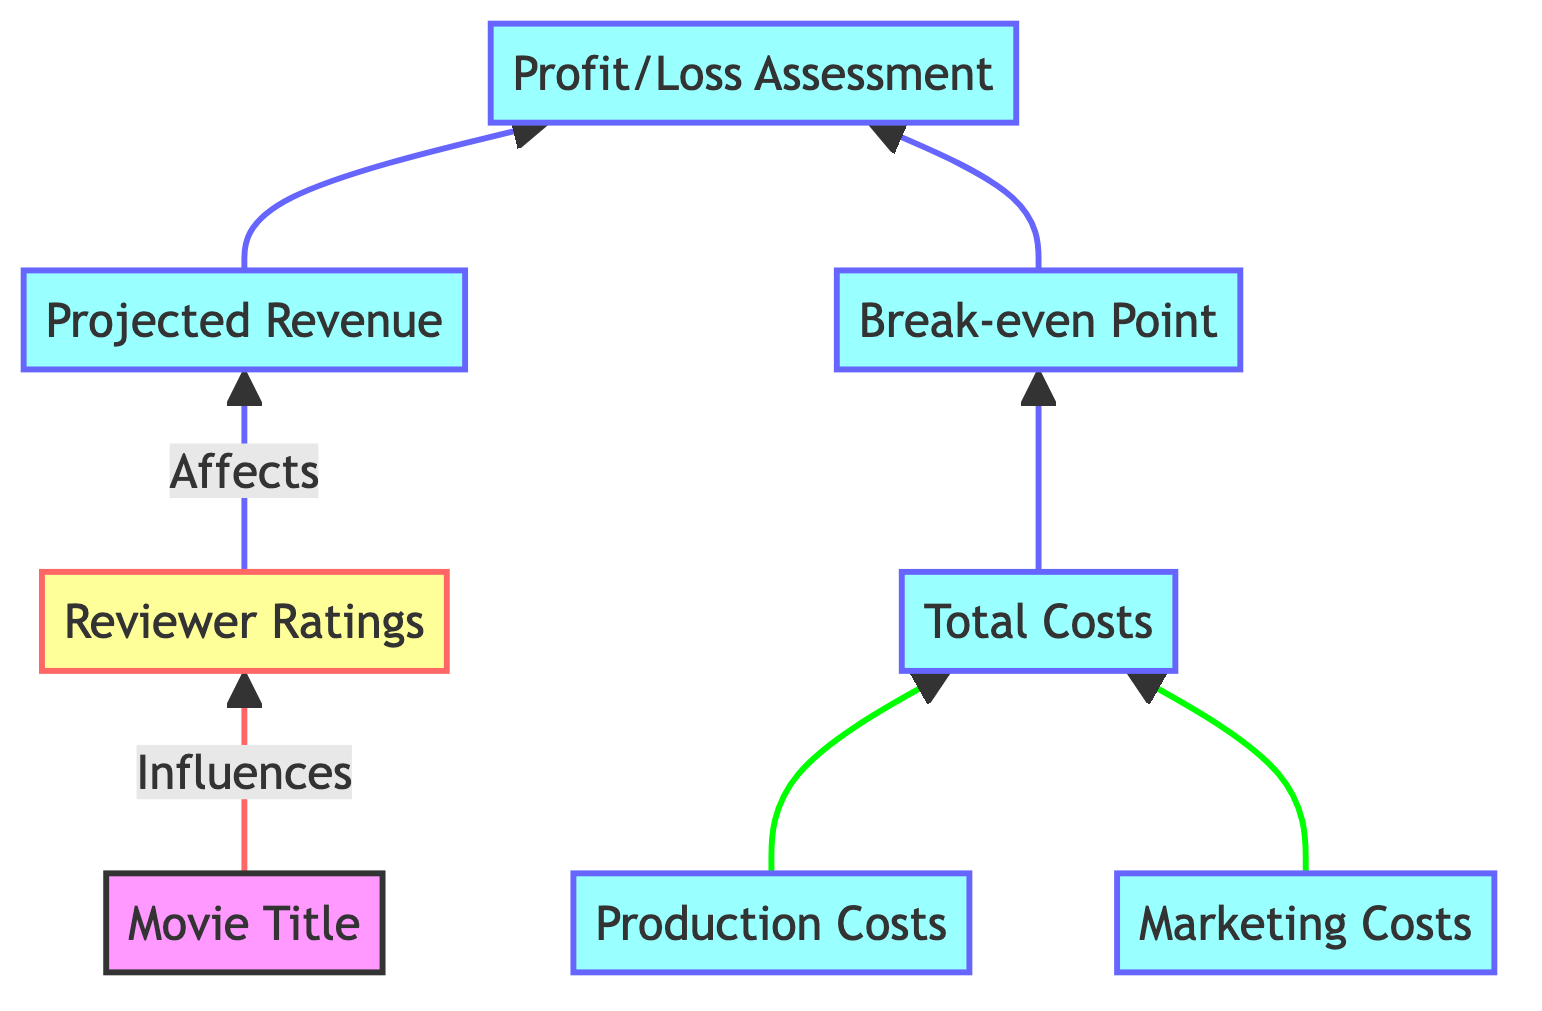What is the first element in the flow chart? The first element is "Movie Title," which indicates the name of the movie being screened.
Answer: Movie Title How many types of costs are included in the total costs? The flowchart shows two types of costs: Production Costs and Marketing Costs, which together sum up to form Total Costs.
Answer: Two What influences the Projected Revenue? Projected Revenue is influenced by Reviewer Ratings, which reflect the anticipated popularity based on reviews.
Answer: Reviewer Ratings What connects Total Costs to the Break-even Point? Total Costs directly leads to the Break-even Point, indicating that the break-even sales are determined by the total expenses incurred.
Answer: Total Costs Which element directly leads to Profit/Loss Assessment? Profit/Loss Assessment is determined by both Projected Revenue and the Break-even Point, blending these elements for the financial evaluation.
Answer: Projected Revenue, Break-even Point What are the two main components included in the Total Costs? The Total Costs are comprised of Production Costs and Marketing Costs, which are both added together in this assessment.
Answer: Production Costs, Marketing Costs If Production Costs are high but Reviewer Ratings are low, what can be inferred about the Profit/Loss Assessment? If Production Costs are high and Reviewer Ratings are low, it suggests that Projected Revenue will likely be low, leading to a negative Profit/Loss Assessment.
Answer: Likely loss Which flowchart element is italicized, indicating its review-related nature? The element that is italicized is "Reviewer Ratings," highlighting its importance in evaluating the movie's potential success based on reviews.
Answer: Reviewer Ratings What leads to the assessment of whether there is a profit or loss from the movie? The Profit/Loss Assessment is based on comparing Projected Revenue with Total Costs, determining financial success or failure.
Answer: Projected Revenue vs Total Costs 